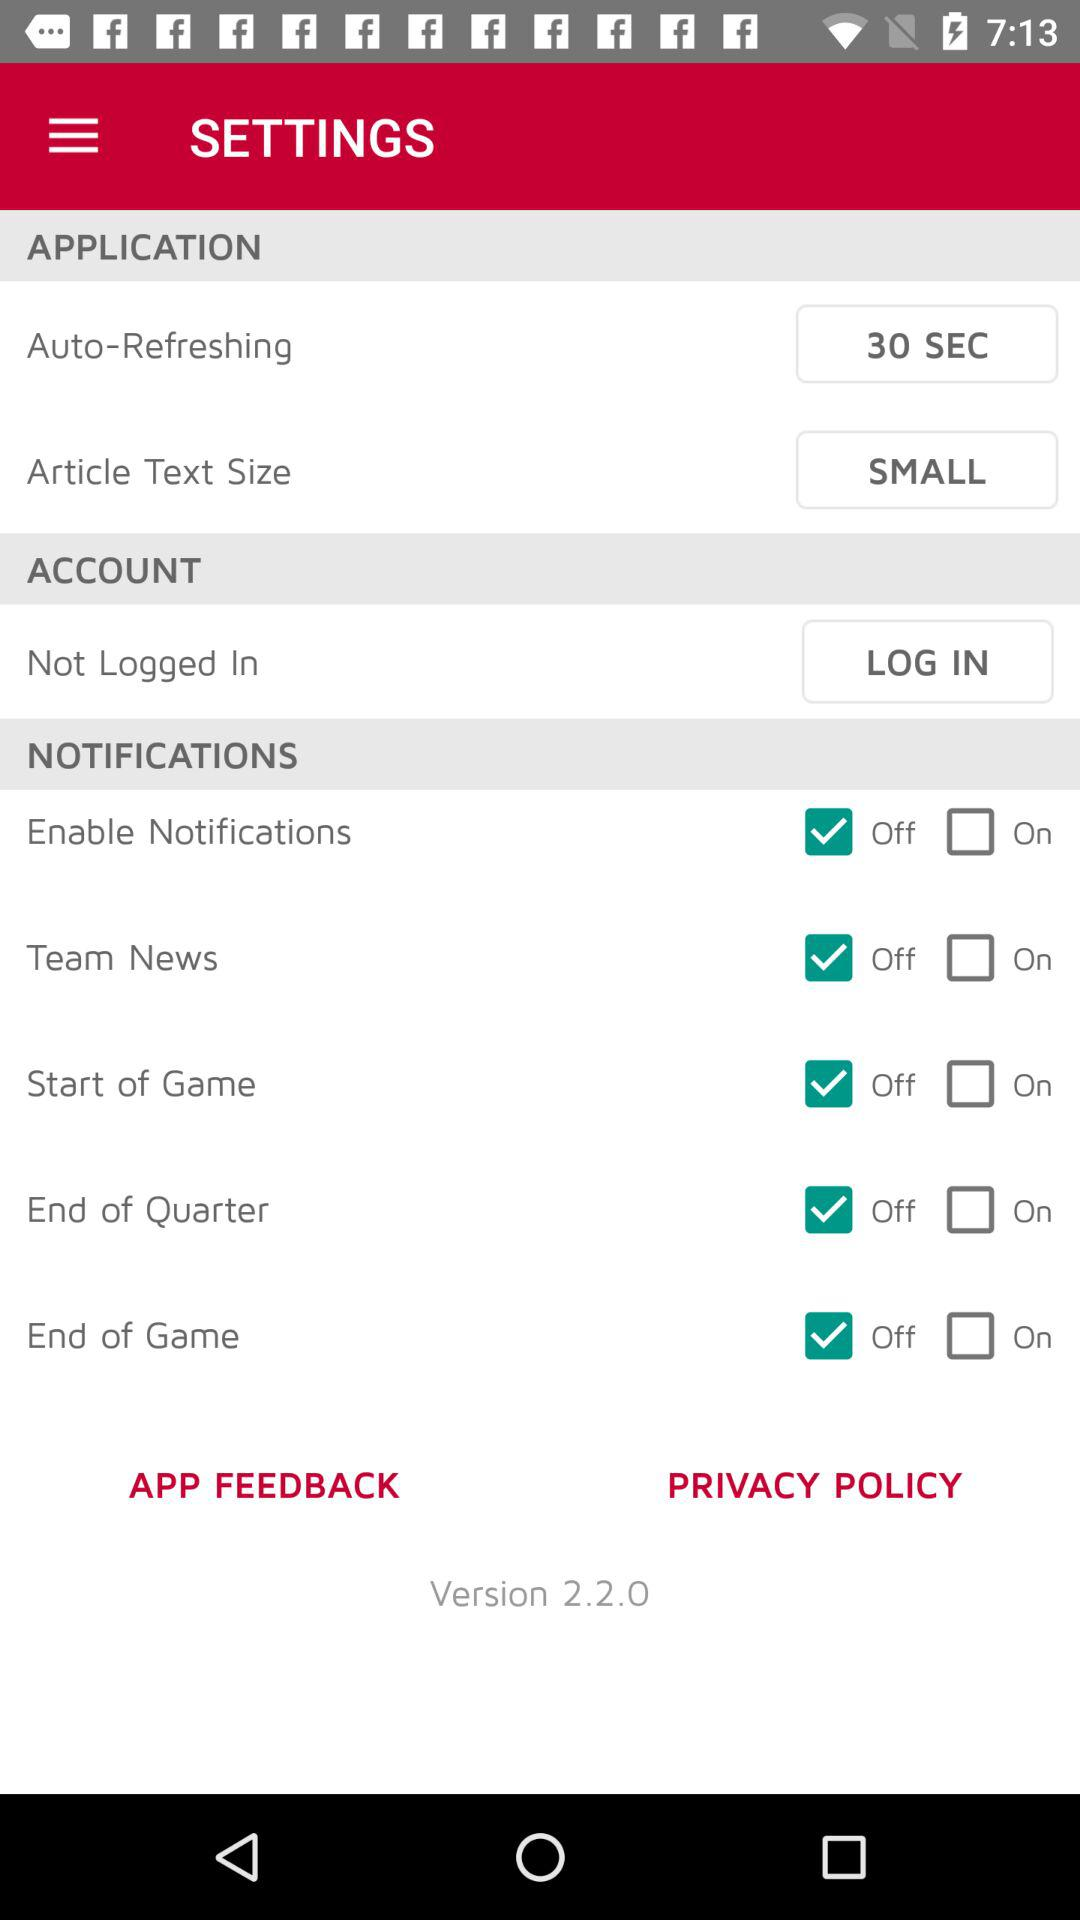Is "Start of Game" on or off? "Start of Game" is off. 